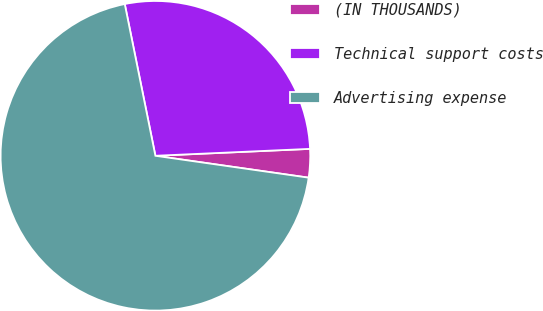Convert chart to OTSL. <chart><loc_0><loc_0><loc_500><loc_500><pie_chart><fcel>(IN THOUSANDS)<fcel>Technical support costs<fcel>Advertising expense<nl><fcel>2.97%<fcel>27.46%<fcel>69.57%<nl></chart> 